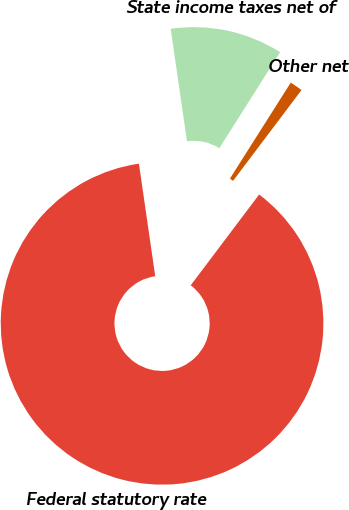<chart> <loc_0><loc_0><loc_500><loc_500><pie_chart><fcel>Federal statutory rate<fcel>State income taxes net of<fcel>Other net<nl><fcel>87.43%<fcel>11.28%<fcel>1.29%<nl></chart> 